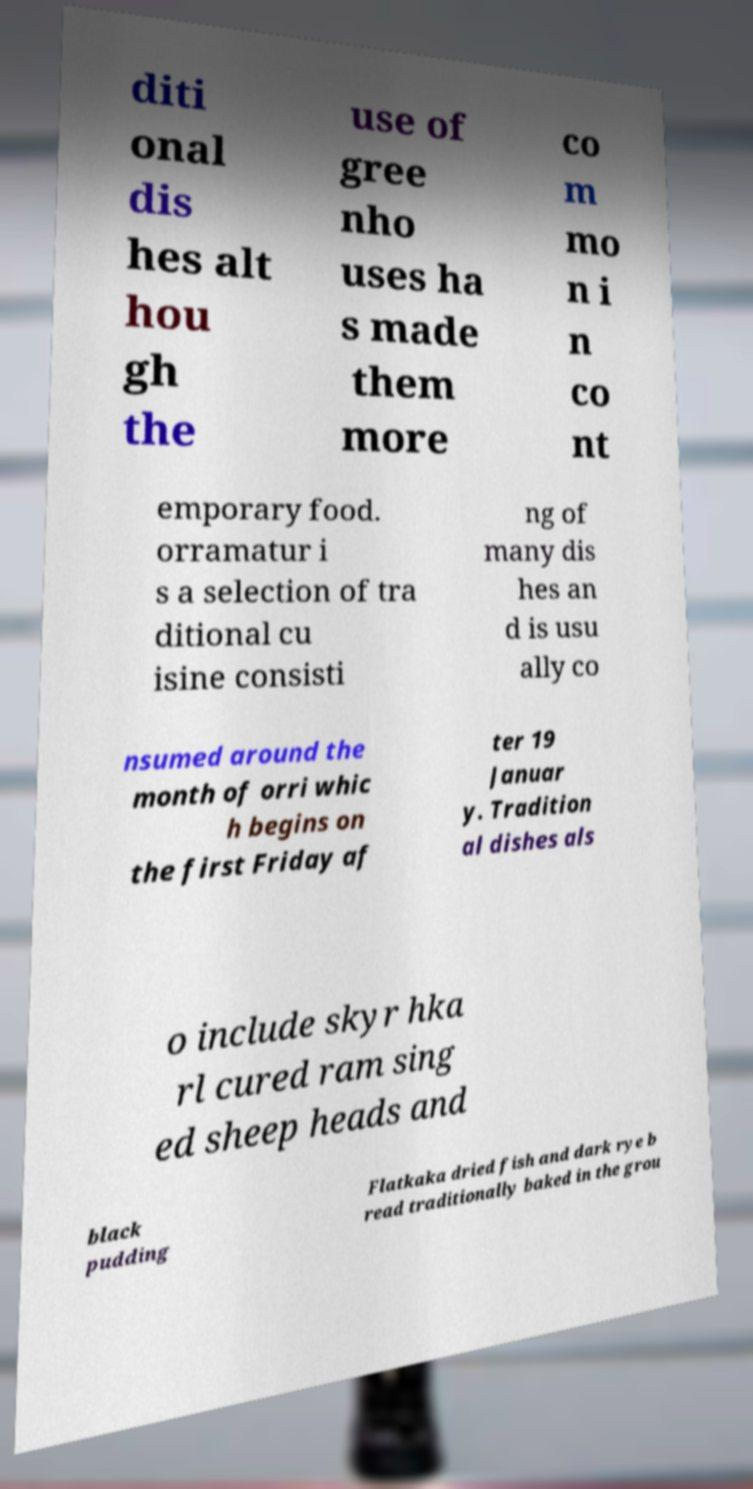There's text embedded in this image that I need extracted. Can you transcribe it verbatim? diti onal dis hes alt hou gh the use of gree nho uses ha s made them more co m mo n i n co nt emporary food. orramatur i s a selection of tra ditional cu isine consisti ng of many dis hes an d is usu ally co nsumed around the month of orri whic h begins on the first Friday af ter 19 Januar y. Tradition al dishes als o include skyr hka rl cured ram sing ed sheep heads and black pudding Flatkaka dried fish and dark rye b read traditionally baked in the grou 